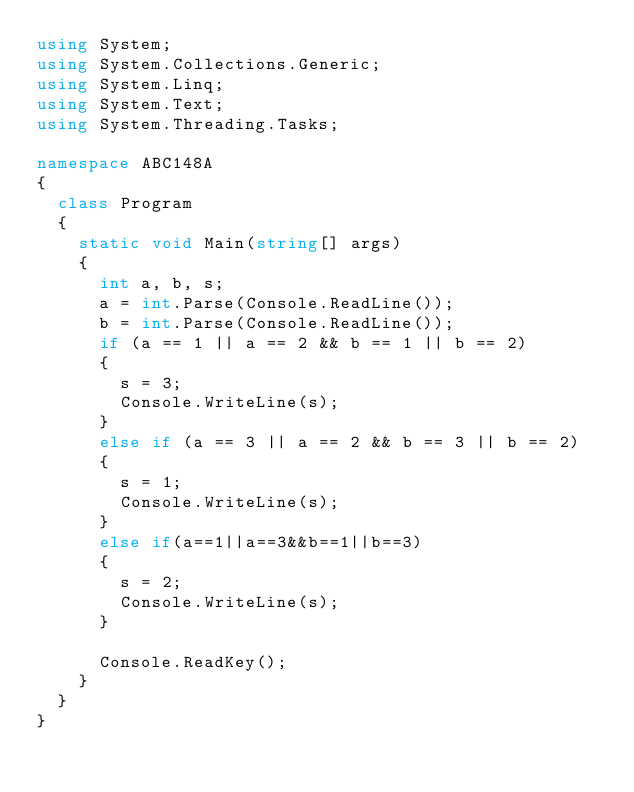Convert code to text. <code><loc_0><loc_0><loc_500><loc_500><_C#_>using System;
using System.Collections.Generic;
using System.Linq;
using System.Text;
using System.Threading.Tasks;

namespace ABC148A
{
	class Program
	{
		static void Main(string[] args)
		{
			int a, b, s;
			a = int.Parse(Console.ReadLine());
			b = int.Parse(Console.ReadLine());
			if (a == 1 || a == 2 && b == 1 || b == 2)
			{
				s = 3;
				Console.WriteLine(s);
			}
			else if (a == 3 || a == 2 && b == 3 || b == 2)
			{
				s = 1;
				Console.WriteLine(s);
			}
			else if(a==1||a==3&&b==1||b==3)
			{
				s = 2;
				Console.WriteLine(s);
			}
			
			Console.ReadKey();
		}
	}
}
</code> 